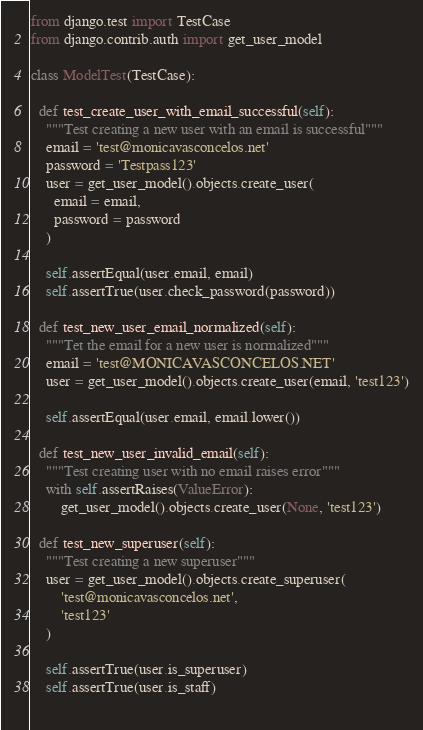<code> <loc_0><loc_0><loc_500><loc_500><_Python_>from django.test import TestCase
from django.contrib.auth import get_user_model

class ModelTest(TestCase):
  
  def test_create_user_with_email_successful(self):
    """Test creating a new user with an email is successful"""
    email = 'test@monicavasconcelos.net'
    password = 'Testpass123'
    user = get_user_model().objects.create_user(
      email = email,
      password = password
    )
    
    self.assertEqual(user.email, email)
    self.assertTrue(user.check_password(password))
    
  def test_new_user_email_normalized(self):
    """Tet the email for a new user is normalized"""
    email = 'test@MONICAVASCONCELOS.NET'
    user = get_user_model().objects.create_user(email, 'test123')
    
    self.assertEqual(user.email, email.lower())
    
  def test_new_user_invalid_email(self):
    """Test creating user with no email raises error"""
    with self.assertRaises(ValueError):
        get_user_model().objects.create_user(None, 'test123')
      
  def test_new_superuser(self):
    """Test creating a new superuser"""
    user = get_user_model().objects.create_superuser(
        'test@monicavasconcelos.net',
        'test123'
    )

    self.assertTrue(user.is_superuser)
    self.assertTrue(user.is_staff)
      </code> 